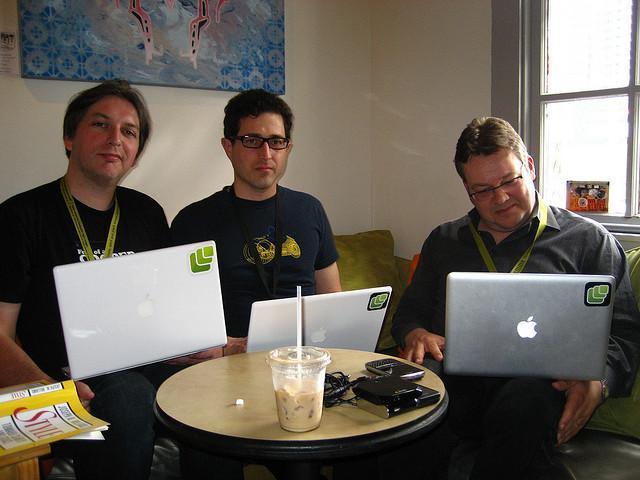How many laptops?
Give a very brief answer. 3. How many people are in the picture?
Give a very brief answer. 3. How many people can be seen?
Give a very brief answer. 3. How many laptops can you see?
Give a very brief answer. 3. How many couches are visible?
Give a very brief answer. 2. 